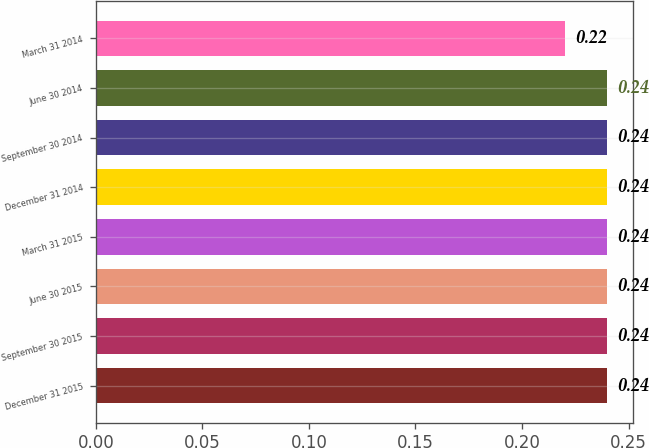<chart> <loc_0><loc_0><loc_500><loc_500><bar_chart><fcel>December 31 2015<fcel>September 30 2015<fcel>June 30 2015<fcel>March 31 2015<fcel>December 31 2014<fcel>September 30 2014<fcel>June 30 2014<fcel>March 31 2014<nl><fcel>0.24<fcel>0.24<fcel>0.24<fcel>0.24<fcel>0.24<fcel>0.24<fcel>0.24<fcel>0.22<nl></chart> 